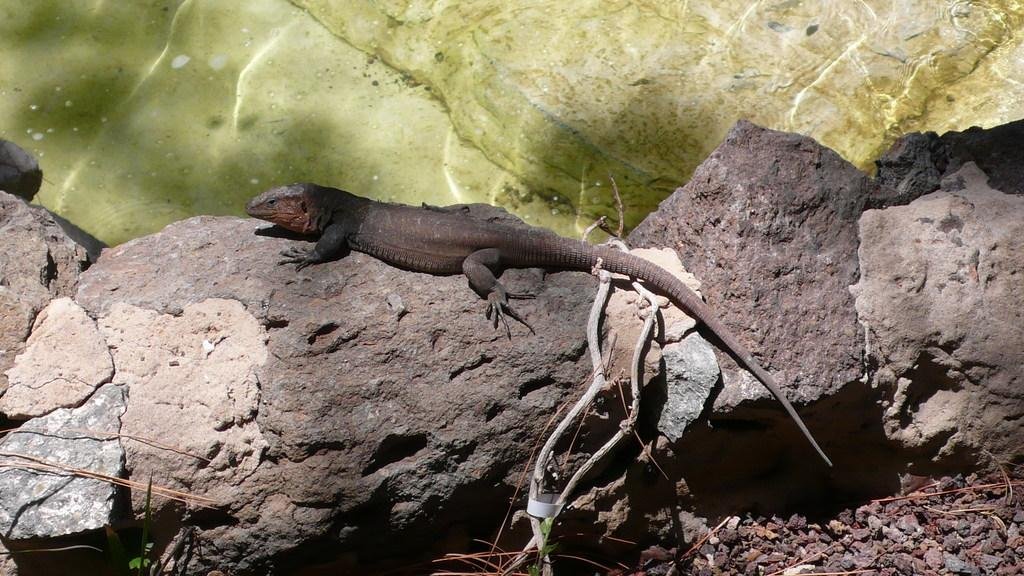What type of animal is in the image? There is a lizard in the image. Where is the lizard located? The lizard is on the rocks in the image. What other objects can be seen in the image? There are rocks, twigs, and small stones in the image. What color is the background of the image? The background of the image is green. What type of quill is the lizard using to write in the image? There is no quill present in the image, and the lizard is not writing. Where is the library located in the image? There is no library present in the image. 